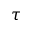Convert formula to latex. <formula><loc_0><loc_0><loc_500><loc_500>\tau</formula> 